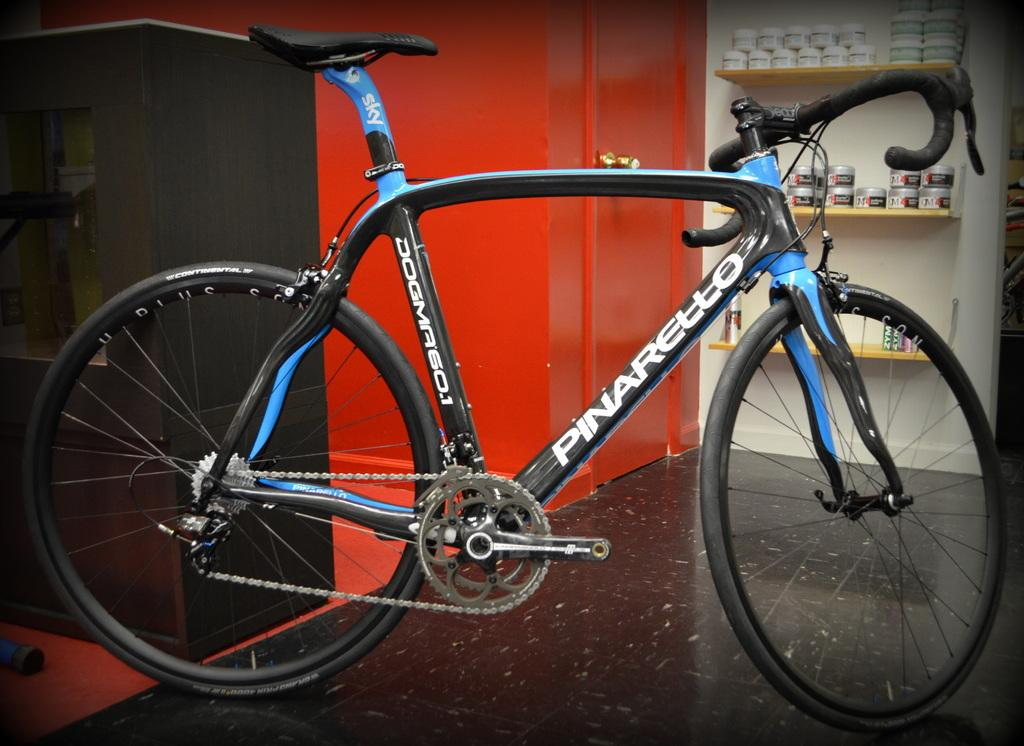What object is placed on the floor in the image? There is a bicycle on the floor in the image. What is the color of the door in the image? The door in the image is red. What type of furniture is present in the image? There are shelves in the image. What can be found on the shelves in the image? There are objects kept on the shelves in the image. What type of button can be seen on the doctor's coat in the image? There is no doctor or button present in the image; it only features a bicycle, a red door, shelves, and objects on the shelves. 